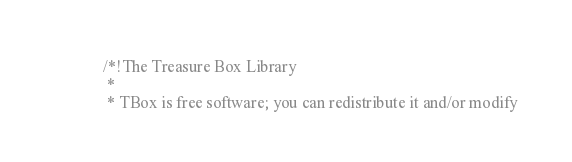Convert code to text. <code><loc_0><loc_0><loc_500><loc_500><_C_>/*!The Treasure Box Library
 * 
 * TBox is free software; you can redistribute it and/or modify</code> 